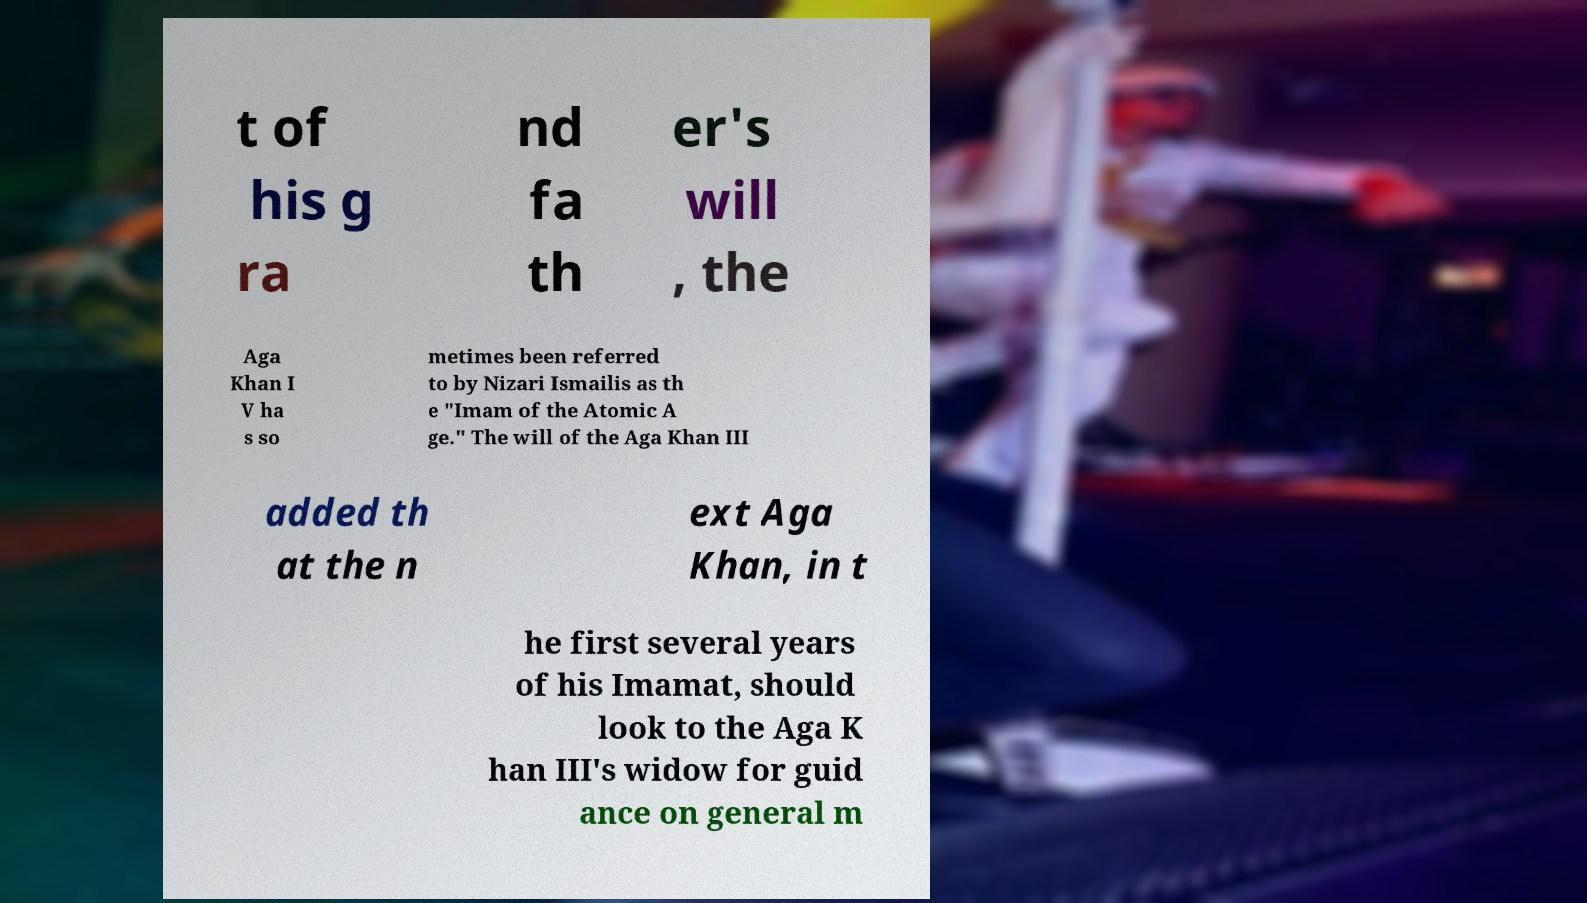For documentation purposes, I need the text within this image transcribed. Could you provide that? t of his g ra nd fa th er's will , the Aga Khan I V ha s so metimes been referred to by Nizari Ismailis as th e "Imam of the Atomic A ge." The will of the Aga Khan III added th at the n ext Aga Khan, in t he first several years of his Imamat, should look to the Aga K han III's widow for guid ance on general m 